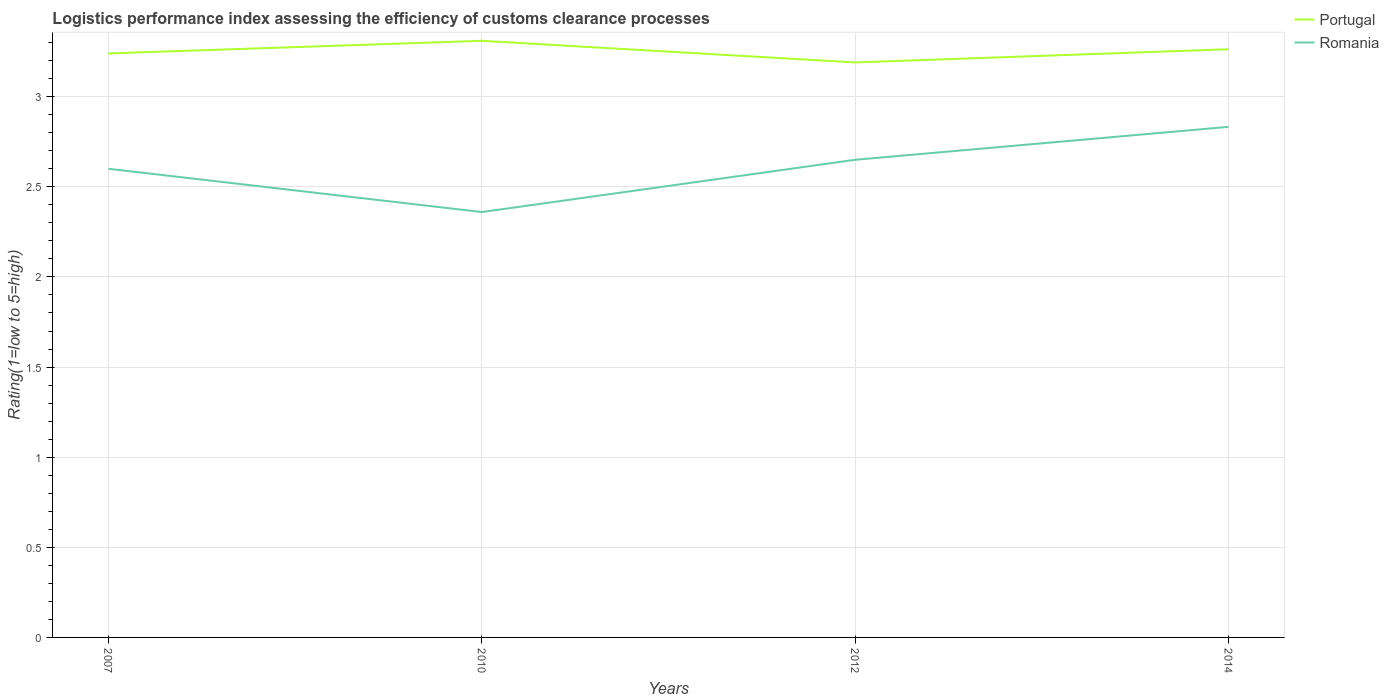Does the line corresponding to Portugal intersect with the line corresponding to Romania?
Offer a terse response. No. Across all years, what is the maximum Logistic performance index in Romania?
Your response must be concise. 2.36. In which year was the Logistic performance index in Romania maximum?
Keep it short and to the point. 2010. What is the total Logistic performance index in Romania in the graph?
Offer a terse response. -0.05. What is the difference between the highest and the second highest Logistic performance index in Portugal?
Keep it short and to the point. 0.12. Is the Logistic performance index in Portugal strictly greater than the Logistic performance index in Romania over the years?
Offer a terse response. No. How many lines are there?
Your answer should be compact. 2. What is the difference between two consecutive major ticks on the Y-axis?
Your answer should be very brief. 0.5. Does the graph contain any zero values?
Your answer should be very brief. No. Does the graph contain grids?
Your answer should be compact. Yes. How many legend labels are there?
Your answer should be compact. 2. What is the title of the graph?
Make the answer very short. Logistics performance index assessing the efficiency of customs clearance processes. Does "Jamaica" appear as one of the legend labels in the graph?
Keep it short and to the point. No. What is the label or title of the Y-axis?
Make the answer very short. Rating(1=low to 5=high). What is the Rating(1=low to 5=high) in Portugal in 2007?
Offer a terse response. 3.24. What is the Rating(1=low to 5=high) of Portugal in 2010?
Make the answer very short. 3.31. What is the Rating(1=low to 5=high) in Romania in 2010?
Keep it short and to the point. 2.36. What is the Rating(1=low to 5=high) of Portugal in 2012?
Provide a succinct answer. 3.19. What is the Rating(1=low to 5=high) in Romania in 2012?
Offer a terse response. 2.65. What is the Rating(1=low to 5=high) of Portugal in 2014?
Your answer should be very brief. 3.26. What is the Rating(1=low to 5=high) in Romania in 2014?
Your answer should be very brief. 2.83. Across all years, what is the maximum Rating(1=low to 5=high) in Portugal?
Make the answer very short. 3.31. Across all years, what is the maximum Rating(1=low to 5=high) of Romania?
Your answer should be compact. 2.83. Across all years, what is the minimum Rating(1=low to 5=high) in Portugal?
Ensure brevity in your answer.  3.19. Across all years, what is the minimum Rating(1=low to 5=high) in Romania?
Keep it short and to the point. 2.36. What is the total Rating(1=low to 5=high) of Portugal in the graph?
Keep it short and to the point. 13. What is the total Rating(1=low to 5=high) in Romania in the graph?
Give a very brief answer. 10.44. What is the difference between the Rating(1=low to 5=high) in Portugal in 2007 and that in 2010?
Ensure brevity in your answer.  -0.07. What is the difference between the Rating(1=low to 5=high) in Romania in 2007 and that in 2010?
Your answer should be compact. 0.24. What is the difference between the Rating(1=low to 5=high) of Romania in 2007 and that in 2012?
Keep it short and to the point. -0.05. What is the difference between the Rating(1=low to 5=high) of Portugal in 2007 and that in 2014?
Make the answer very short. -0.02. What is the difference between the Rating(1=low to 5=high) of Romania in 2007 and that in 2014?
Offer a very short reply. -0.23. What is the difference between the Rating(1=low to 5=high) of Portugal in 2010 and that in 2012?
Make the answer very short. 0.12. What is the difference between the Rating(1=low to 5=high) of Romania in 2010 and that in 2012?
Provide a short and direct response. -0.29. What is the difference between the Rating(1=low to 5=high) in Portugal in 2010 and that in 2014?
Make the answer very short. 0.05. What is the difference between the Rating(1=low to 5=high) of Romania in 2010 and that in 2014?
Provide a succinct answer. -0.47. What is the difference between the Rating(1=low to 5=high) of Portugal in 2012 and that in 2014?
Your response must be concise. -0.07. What is the difference between the Rating(1=low to 5=high) in Romania in 2012 and that in 2014?
Give a very brief answer. -0.18. What is the difference between the Rating(1=low to 5=high) in Portugal in 2007 and the Rating(1=low to 5=high) in Romania in 2010?
Your answer should be compact. 0.88. What is the difference between the Rating(1=low to 5=high) of Portugal in 2007 and the Rating(1=low to 5=high) of Romania in 2012?
Ensure brevity in your answer.  0.59. What is the difference between the Rating(1=low to 5=high) of Portugal in 2007 and the Rating(1=low to 5=high) of Romania in 2014?
Offer a very short reply. 0.41. What is the difference between the Rating(1=low to 5=high) in Portugal in 2010 and the Rating(1=low to 5=high) in Romania in 2012?
Your answer should be compact. 0.66. What is the difference between the Rating(1=low to 5=high) of Portugal in 2010 and the Rating(1=low to 5=high) of Romania in 2014?
Provide a succinct answer. 0.48. What is the difference between the Rating(1=low to 5=high) of Portugal in 2012 and the Rating(1=low to 5=high) of Romania in 2014?
Provide a succinct answer. 0.36. What is the average Rating(1=low to 5=high) of Portugal per year?
Offer a very short reply. 3.25. What is the average Rating(1=low to 5=high) in Romania per year?
Provide a succinct answer. 2.61. In the year 2007, what is the difference between the Rating(1=low to 5=high) in Portugal and Rating(1=low to 5=high) in Romania?
Offer a terse response. 0.64. In the year 2012, what is the difference between the Rating(1=low to 5=high) in Portugal and Rating(1=low to 5=high) in Romania?
Make the answer very short. 0.54. In the year 2014, what is the difference between the Rating(1=low to 5=high) of Portugal and Rating(1=low to 5=high) of Romania?
Ensure brevity in your answer.  0.43. What is the ratio of the Rating(1=low to 5=high) of Portugal in 2007 to that in 2010?
Your answer should be very brief. 0.98. What is the ratio of the Rating(1=low to 5=high) in Romania in 2007 to that in 2010?
Your response must be concise. 1.1. What is the ratio of the Rating(1=low to 5=high) in Portugal in 2007 to that in 2012?
Offer a terse response. 1.02. What is the ratio of the Rating(1=low to 5=high) of Romania in 2007 to that in 2012?
Give a very brief answer. 0.98. What is the ratio of the Rating(1=low to 5=high) of Romania in 2007 to that in 2014?
Your answer should be very brief. 0.92. What is the ratio of the Rating(1=low to 5=high) of Portugal in 2010 to that in 2012?
Provide a succinct answer. 1.04. What is the ratio of the Rating(1=low to 5=high) in Romania in 2010 to that in 2012?
Give a very brief answer. 0.89. What is the ratio of the Rating(1=low to 5=high) of Portugal in 2010 to that in 2014?
Ensure brevity in your answer.  1.01. What is the ratio of the Rating(1=low to 5=high) in Romania in 2010 to that in 2014?
Offer a terse response. 0.83. What is the ratio of the Rating(1=low to 5=high) of Portugal in 2012 to that in 2014?
Offer a very short reply. 0.98. What is the ratio of the Rating(1=low to 5=high) of Romania in 2012 to that in 2014?
Keep it short and to the point. 0.94. What is the difference between the highest and the second highest Rating(1=low to 5=high) of Portugal?
Offer a terse response. 0.05. What is the difference between the highest and the second highest Rating(1=low to 5=high) in Romania?
Your answer should be compact. 0.18. What is the difference between the highest and the lowest Rating(1=low to 5=high) in Portugal?
Provide a succinct answer. 0.12. What is the difference between the highest and the lowest Rating(1=low to 5=high) of Romania?
Ensure brevity in your answer.  0.47. 